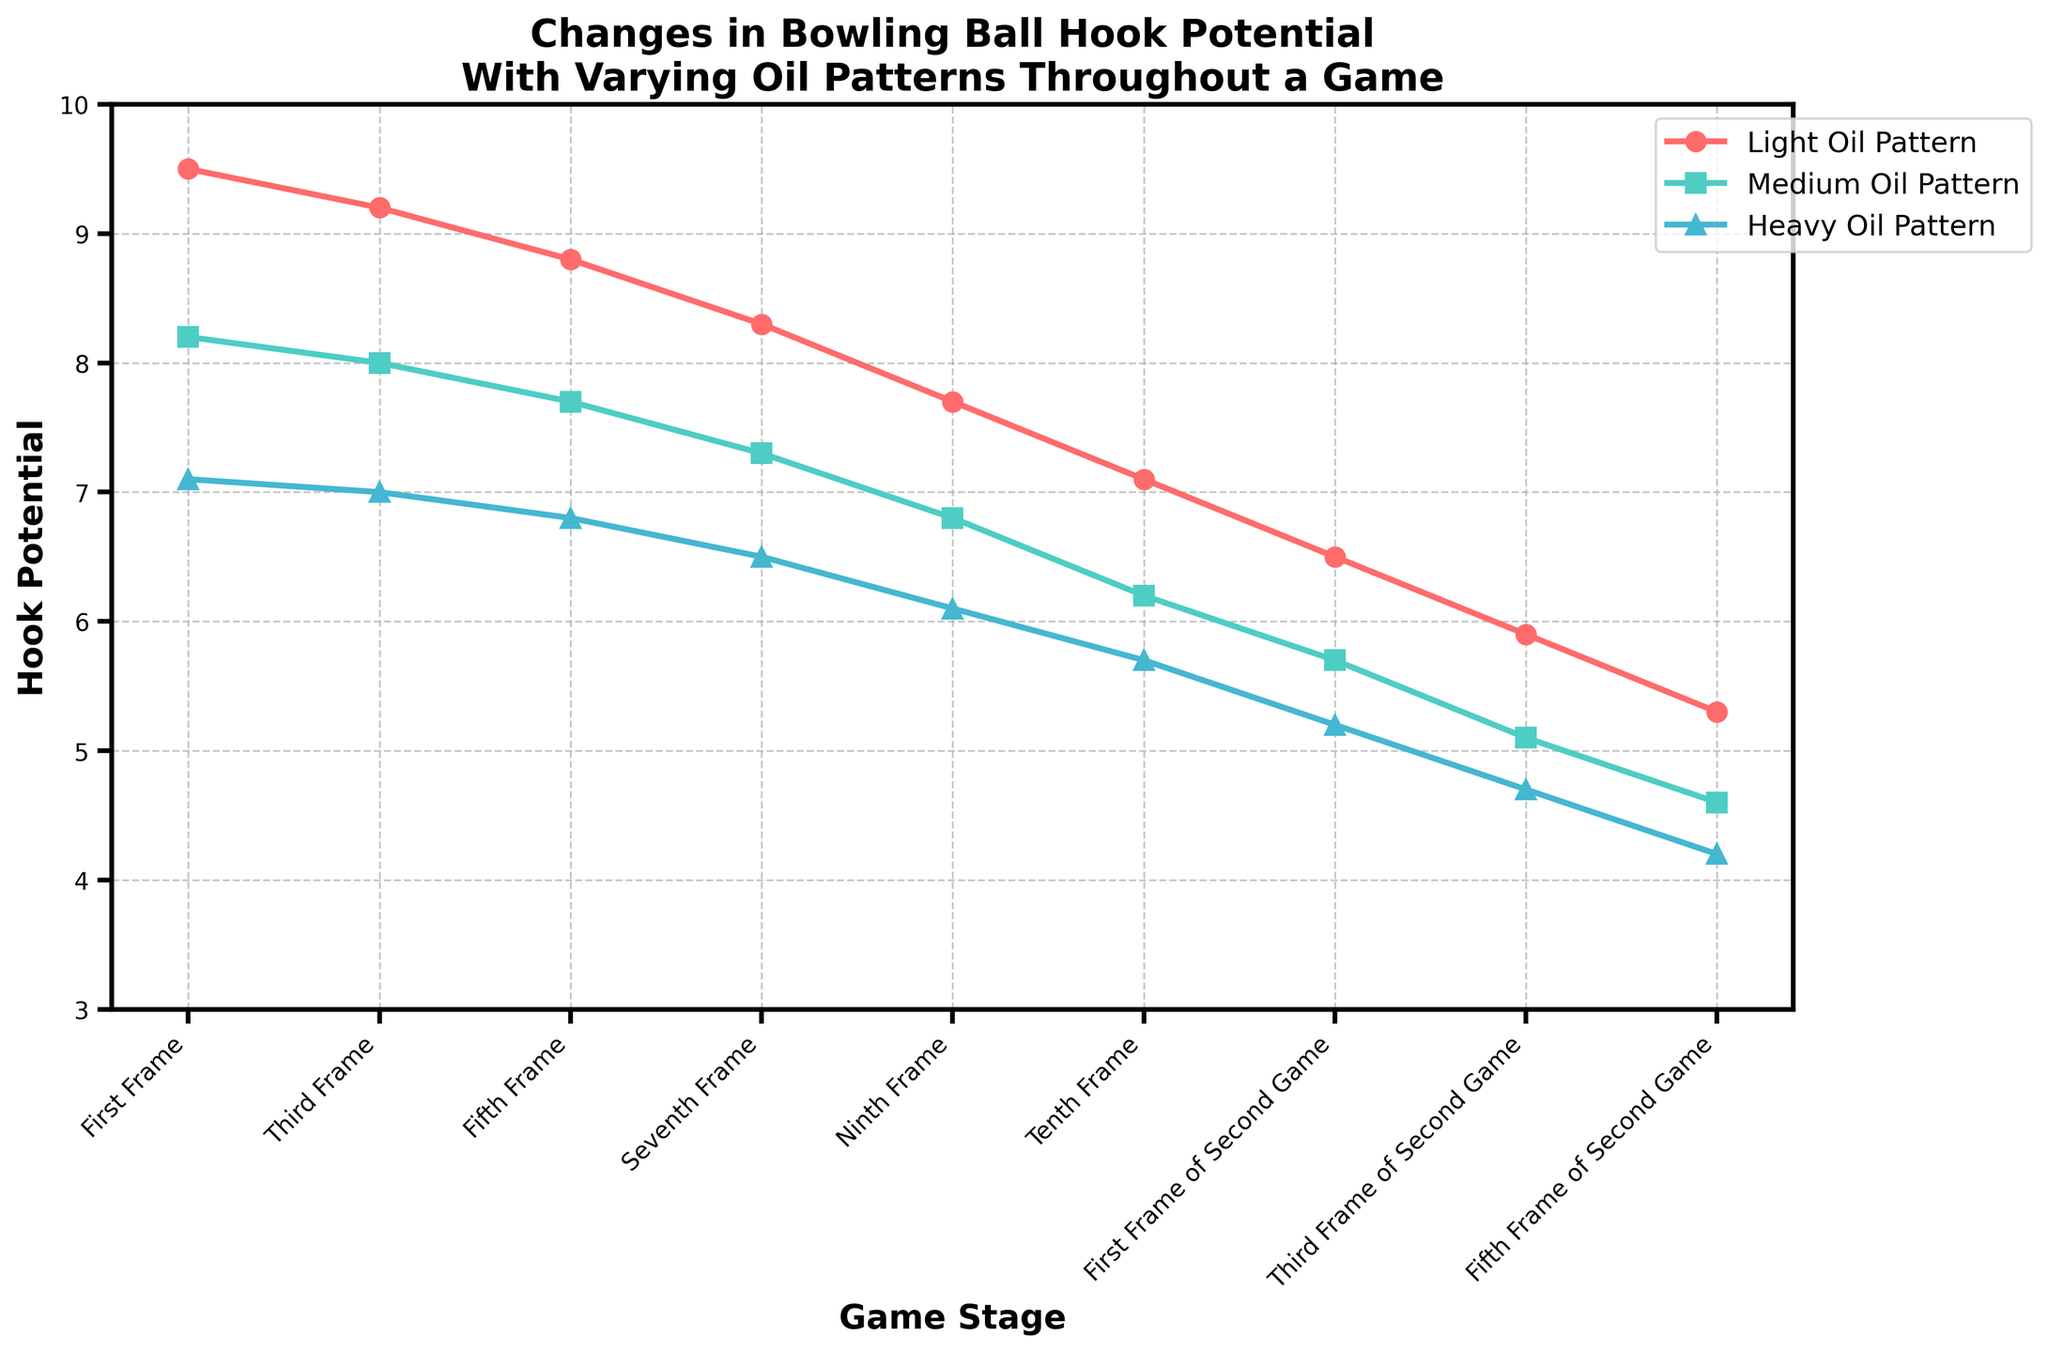Which oil pattern has the highest hook potential in the first frame? In the first frame, look at the data points for each oil pattern. The Light Oil Pattern has the highest value among them.
Answer: Light Oil Pattern How does the hook potential for the Heavy Oil Pattern change from the first frame to the third frame of the second game? Compare the values for the Heavy Oil Pattern from the first frame (7.1) to the third frame of the second game (4.7). Calculate the difference: 7.1 - 4.7.
Answer: Decreases by 2.4 Which frame shows the largest decrease in hook potential for the Medium Oil Pattern compared to the previous frame? Check the differences between consecutive frames for the Medium Oil Pattern. The largest decrease occurs between the First Frame (6.5) and Third Frame (5.1) of the Second Game. Calculate: 6.5 - 5.1 = 1.4.
Answer: First Frame of Second Game to Third Frame of Second Game How many frames have a hook potential greater than 7 for the Light Oil Pattern? Check the values for the Light Oil Pattern. Frames with hook potential greater than 7 are First Frame (9.5), Third Frame (9.2), Fifth Frame (8.8), Seventh Frame (8.3), Ninth Frame (7.7), Tenth Frame (7.1). Count them: 6 frames.
Answer: 6 frames Which oil pattern shows the steepest decline in hook potential throughout the entire game? Look at the overall trend for each oil pattern. The Light Oil Pattern decreases from 9.5 to 5.3 (4.2), Medium Oil Pattern from 8.0 to 4.6 (3.4), Heavy Oil Pattern from 7.1 to 4.2 (2.9). Light Oil Pattern shows the steepest total decline.
Answer: Light Oil Pattern What is the average hook potential for the Heavy Oil Pattern during the first game? First game includes First Frame, Third Frame, Fifth Frame, Seventh Frame, Ninth Frame, Tenth Frame. Add the values: 7.1 + 7.0 + 6.8 + 6.5 + 6.1 + 5.7 = 39.2. The average is 39.2 / 6.
Answer: 6.53 How does the hook potential in the Tenth Frame compare between the Light Oil Pattern and Medium Oil Pattern? In the Tenth Frame, compare values: Light Oil Pattern (7.1) and Medium Oil Pattern (6.2). The Light Oil Pattern is higher by 0.9 units.
Answer: Light Oil Pattern is higher Which oil pattern consistently has the lowest hook potential across all frames? Compare the hook potential values across all frames for each pattern. The Heavy Oil Pattern consistently has the lowest values.
Answer: Heavy Oil Pattern By how much does the hook potential for the Light Oil Pattern change from the Ninth Frame to the Fifth Frame of the Second Game? Compare values: Ninth Frame (7.7) and Fifth Frame of Second Game (5.3). Calculate the difference: 7.7 - 5.3.
Answer: Decreases by 2.4 What visual cues indicate the trend for hook potential changes in the chart? The trend is indicated by the sloping lines for each oil pattern. Each line consistently slopes downwards from left to right, indicating decreasing hook potential as the game progresses.
Answer: Downward sloping lines 